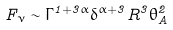<formula> <loc_0><loc_0><loc_500><loc_500>F _ { \nu } \sim \Gamma ^ { 1 + 3 \alpha } \delta ^ { \alpha + 3 } R ^ { 3 } \theta _ { A } ^ { 2 }</formula> 